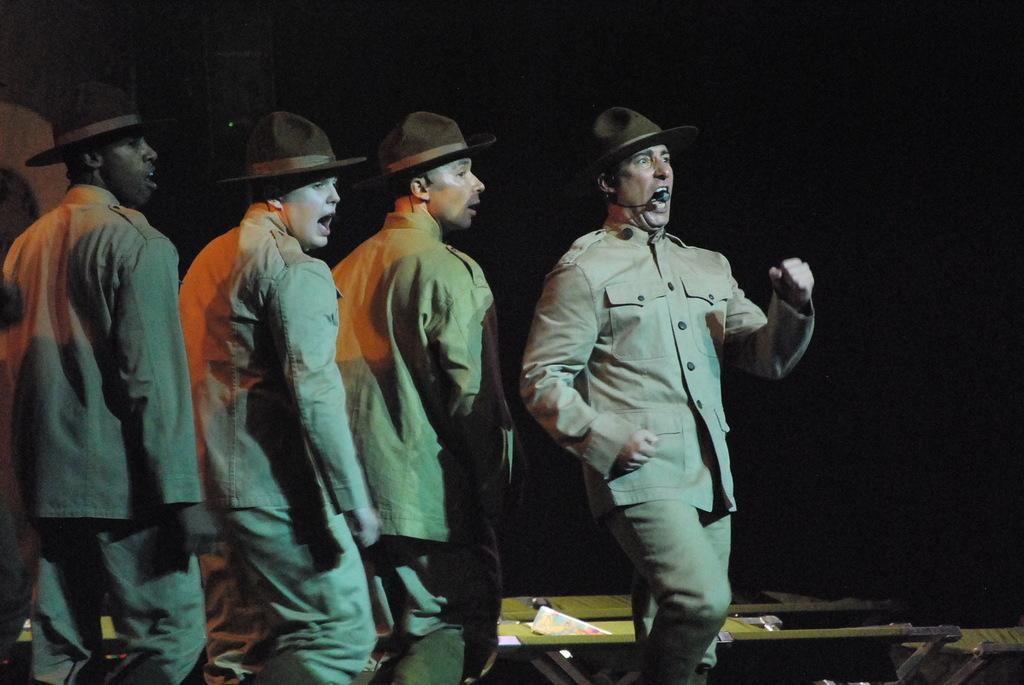Please provide a concise description of this image. In this image there are people. They are wearing hats. Right side there is a person walking. He is singing. Behind him there are few objects. 